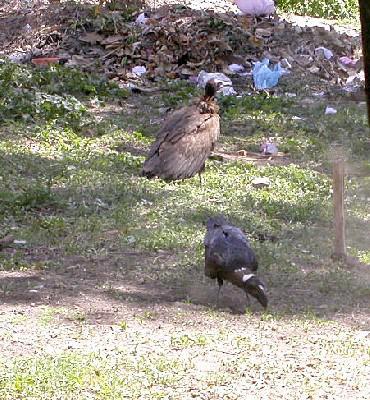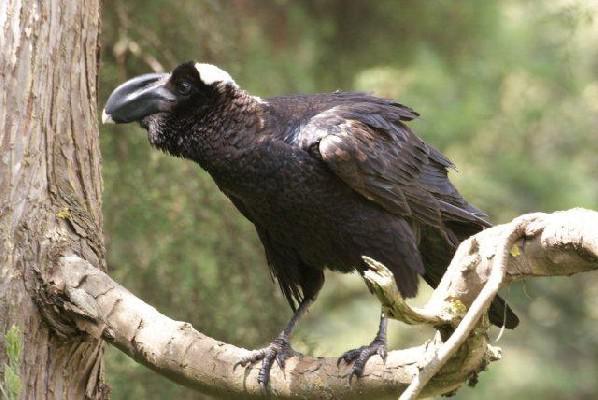The first image is the image on the left, the second image is the image on the right. Examine the images to the left and right. Is the description "An image shows one dark bird perched on a horizontal tree branch." accurate? Answer yes or no. Yes. The first image is the image on the left, the second image is the image on the right. Evaluate the accuracy of this statement regarding the images: "One of the images shows exactly one bird perched on a branch.". Is it true? Answer yes or no. Yes. 